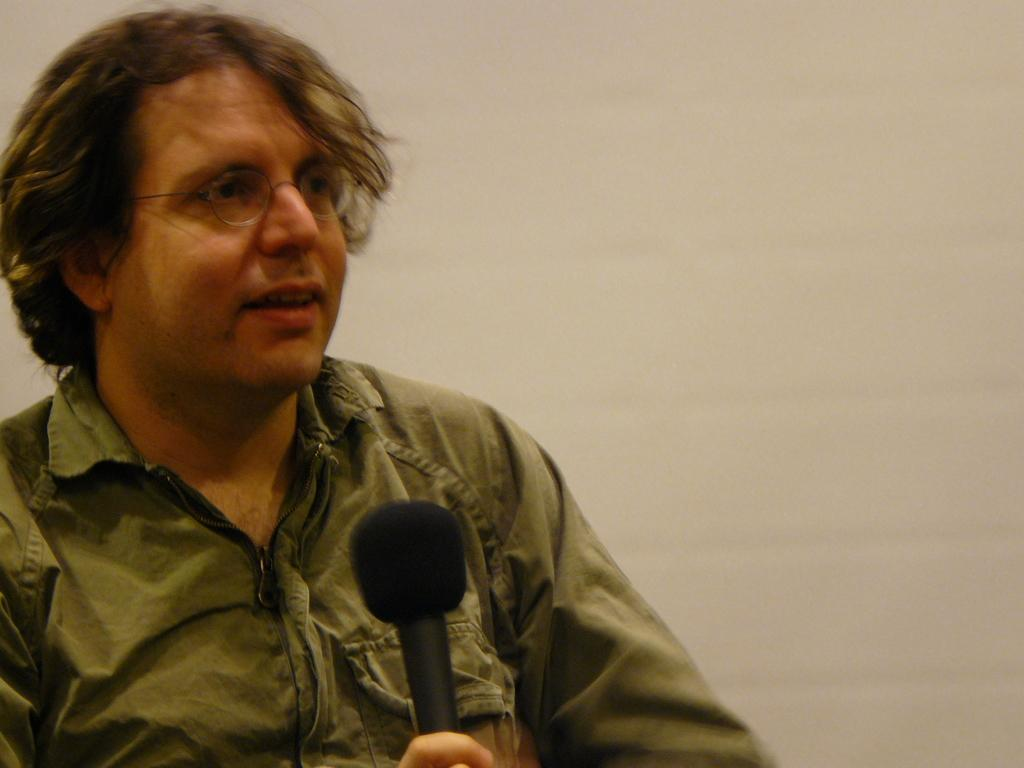What can be seen in the image? There is a person in the image. What is the person holding in his hand? The person is holding a microphone in his hand. Can you describe the person's appearance? The person is wearing spectacles. What is visible in the background of the image? There is a wall in the background of the image. What type of seed is being used to hold the microphone in place? There is no seed present in the image, and the microphone is not being held in place by any seed. 